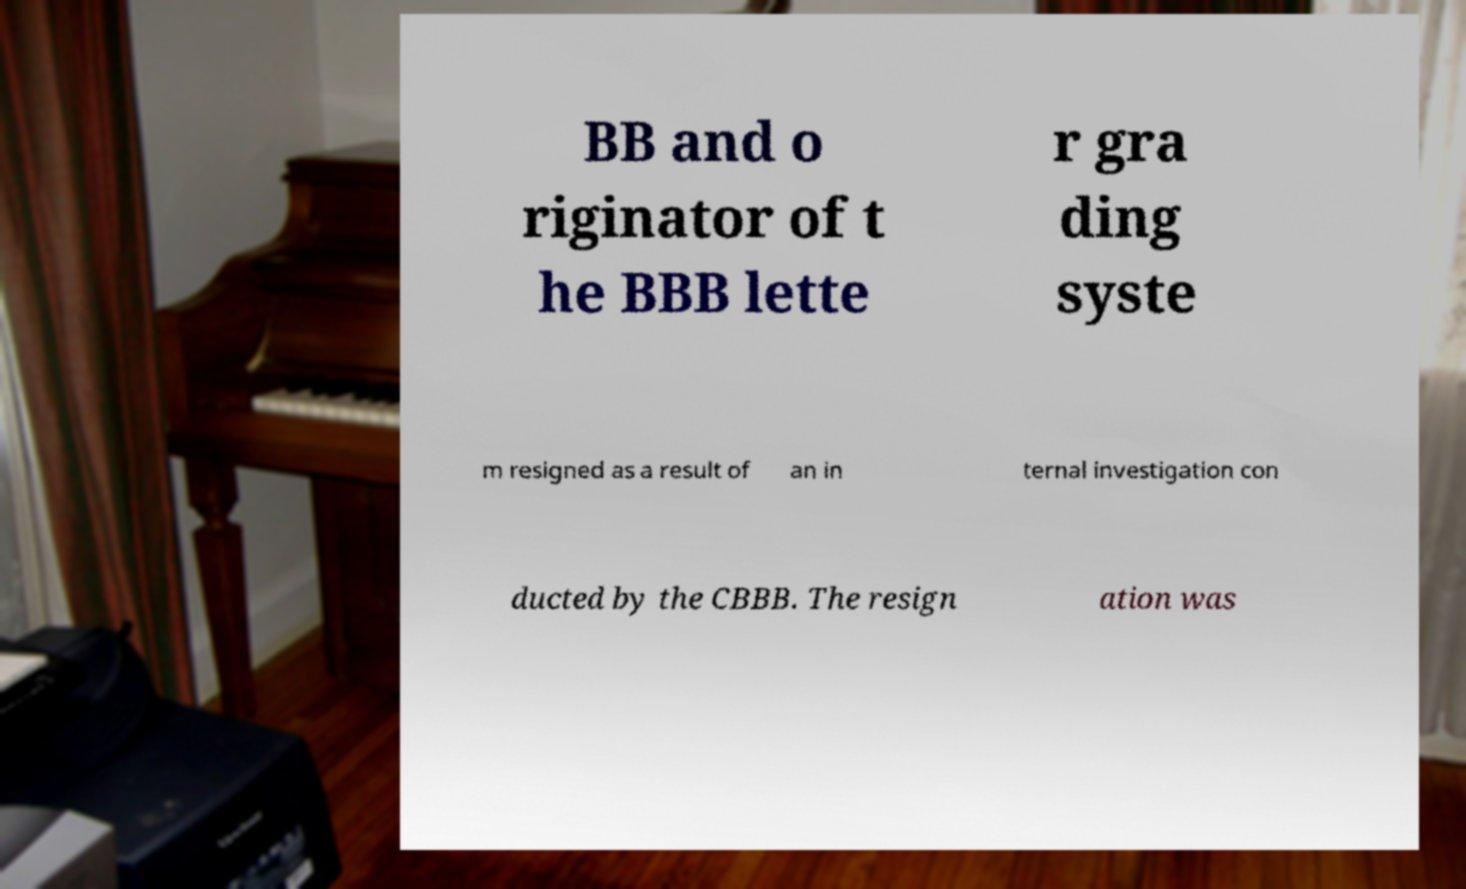Can you read and provide the text displayed in the image?This photo seems to have some interesting text. Can you extract and type it out for me? BB and o riginator of t he BBB lette r gra ding syste m resigned as a result of an in ternal investigation con ducted by the CBBB. The resign ation was 